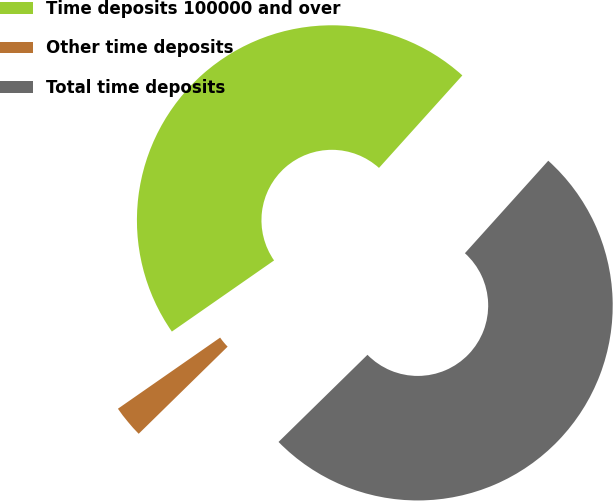Convert chart. <chart><loc_0><loc_0><loc_500><loc_500><pie_chart><fcel>Time deposits 100000 and over<fcel>Other time deposits<fcel>Total time deposits<nl><fcel>46.35%<fcel>2.66%<fcel>50.99%<nl></chart> 